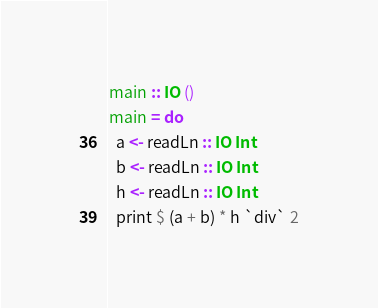<code> <loc_0><loc_0><loc_500><loc_500><_Haskell_>main :: IO ()
main = do
  a <- readLn :: IO Int
  b <- readLn :: IO Int
  h <- readLn :: IO Int
  print $ (a + b) * h `div` 2
</code> 